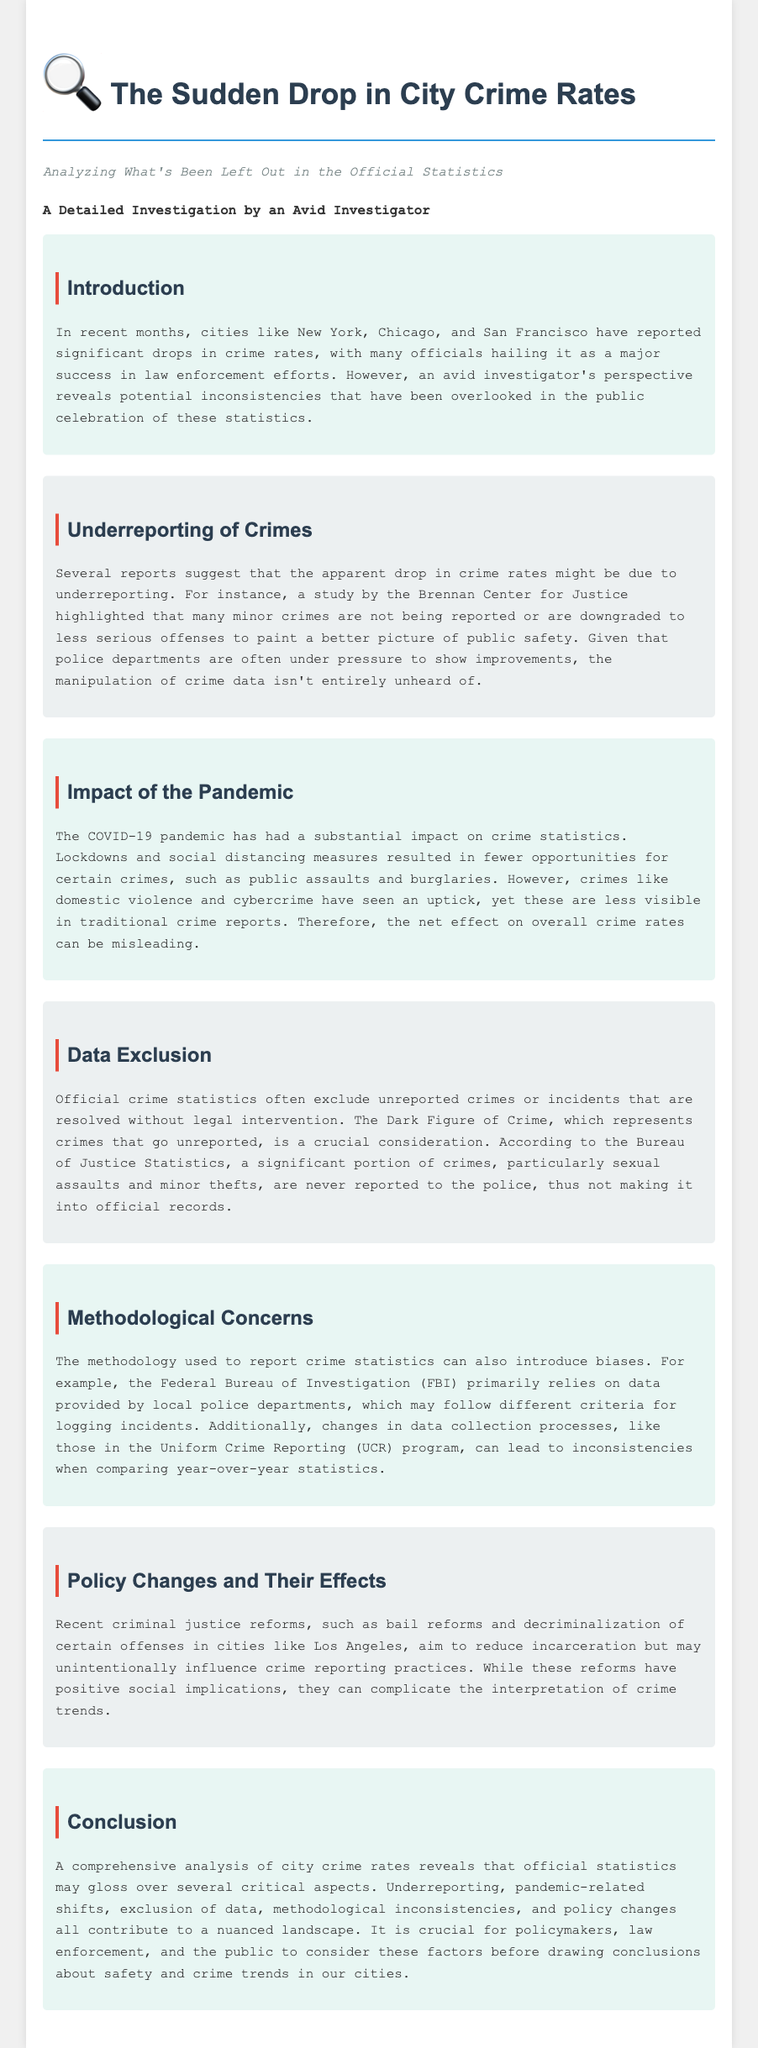what cities reported significant drops in crime rates? The cities mentioned in the document that reported significant drops in crime rates are New York, Chicago, and San Francisco.
Answer: New York, Chicago, San Francisco what is the concept that represents crimes that go unreported? The document refers to the unreported crimes as the "Dark Figure of Crime."
Answer: Dark Figure of Crime which crimes have seen an uptick during the COVID-19 pandemic? According to the document, crimes like domestic violence and cybercrime have seen an increase during the pandemic.
Answer: Domestic violence, cybercrime what does the FBI rely on for reporting crime statistics? The FBI primarily relies on data provided by local police departments for reporting crime statistics.
Answer: Local police departments what is one major issue with the methodology of crime reporting? The methodology issue mentioned is that local police departments may follow different criteria for logging incidents.
Answer: Different criteria what recent criminal justice reform is mentioned in the document? The document mentions bail reforms and decriminalization as recent criminal justice reforms.
Answer: Bail reforms, decriminalization what does the document suggest has been overlooked in crime statistics? The document suggests that underreporting of crimes has been overlooked in the public celebration of crime statistics.
Answer: Underreporting how many major factors contributing to crime rate reporting does the document mention? The document mentions five major factors contributing to the understanding of crime rates.
Answer: Five 